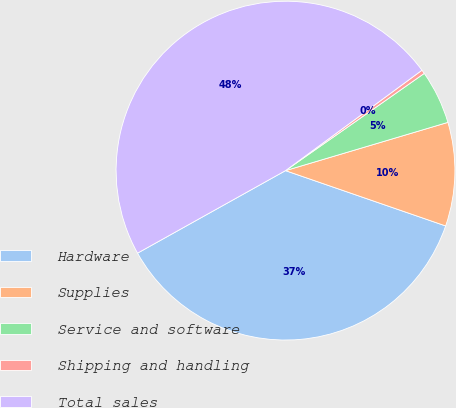Convert chart to OTSL. <chart><loc_0><loc_0><loc_500><loc_500><pie_chart><fcel>Hardware<fcel>Supplies<fcel>Service and software<fcel>Shipping and handling<fcel>Total sales<nl><fcel>36.61%<fcel>9.89%<fcel>5.13%<fcel>0.37%<fcel>48.0%<nl></chart> 